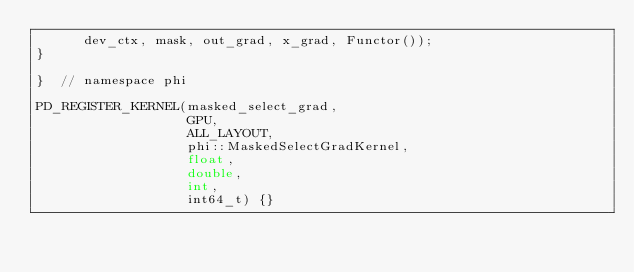<code> <loc_0><loc_0><loc_500><loc_500><_Cuda_>      dev_ctx, mask, out_grad, x_grad, Functor());
}

}  // namespace phi

PD_REGISTER_KERNEL(masked_select_grad,
                   GPU,
                   ALL_LAYOUT,
                   phi::MaskedSelectGradKernel,
                   float,
                   double,
                   int,
                   int64_t) {}
</code> 